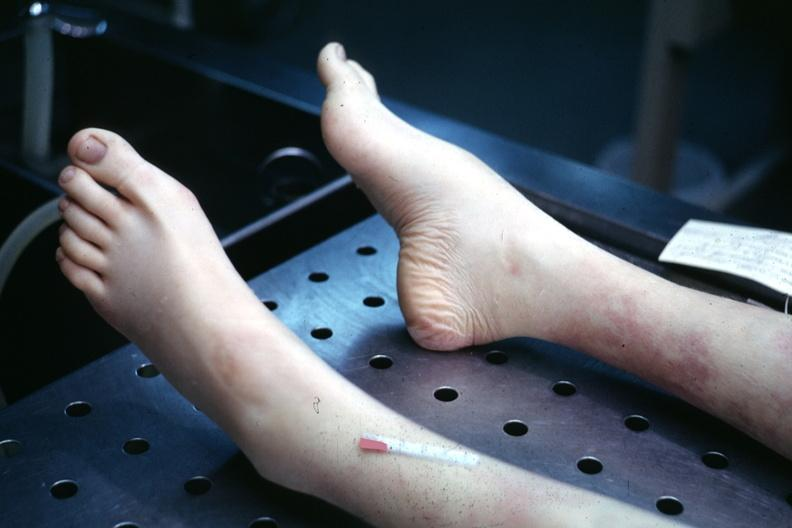what are present?
Answer the question using a single word or phrase. Extremities 